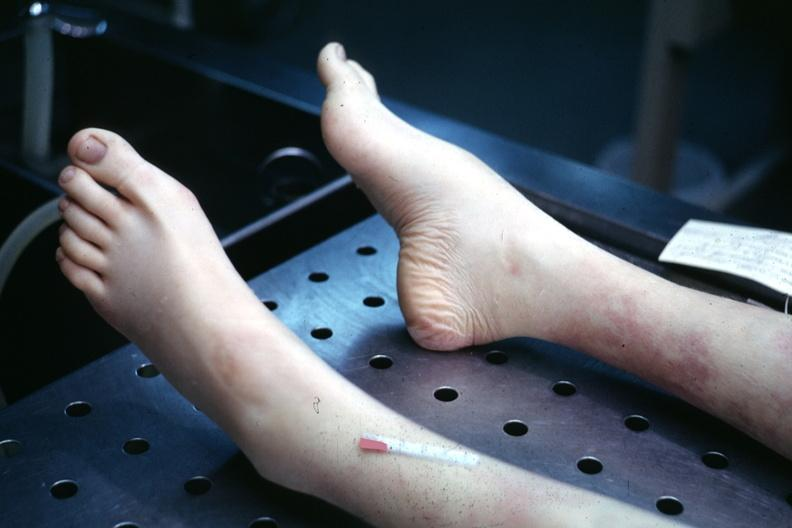what are present?
Answer the question using a single word or phrase. Extremities 